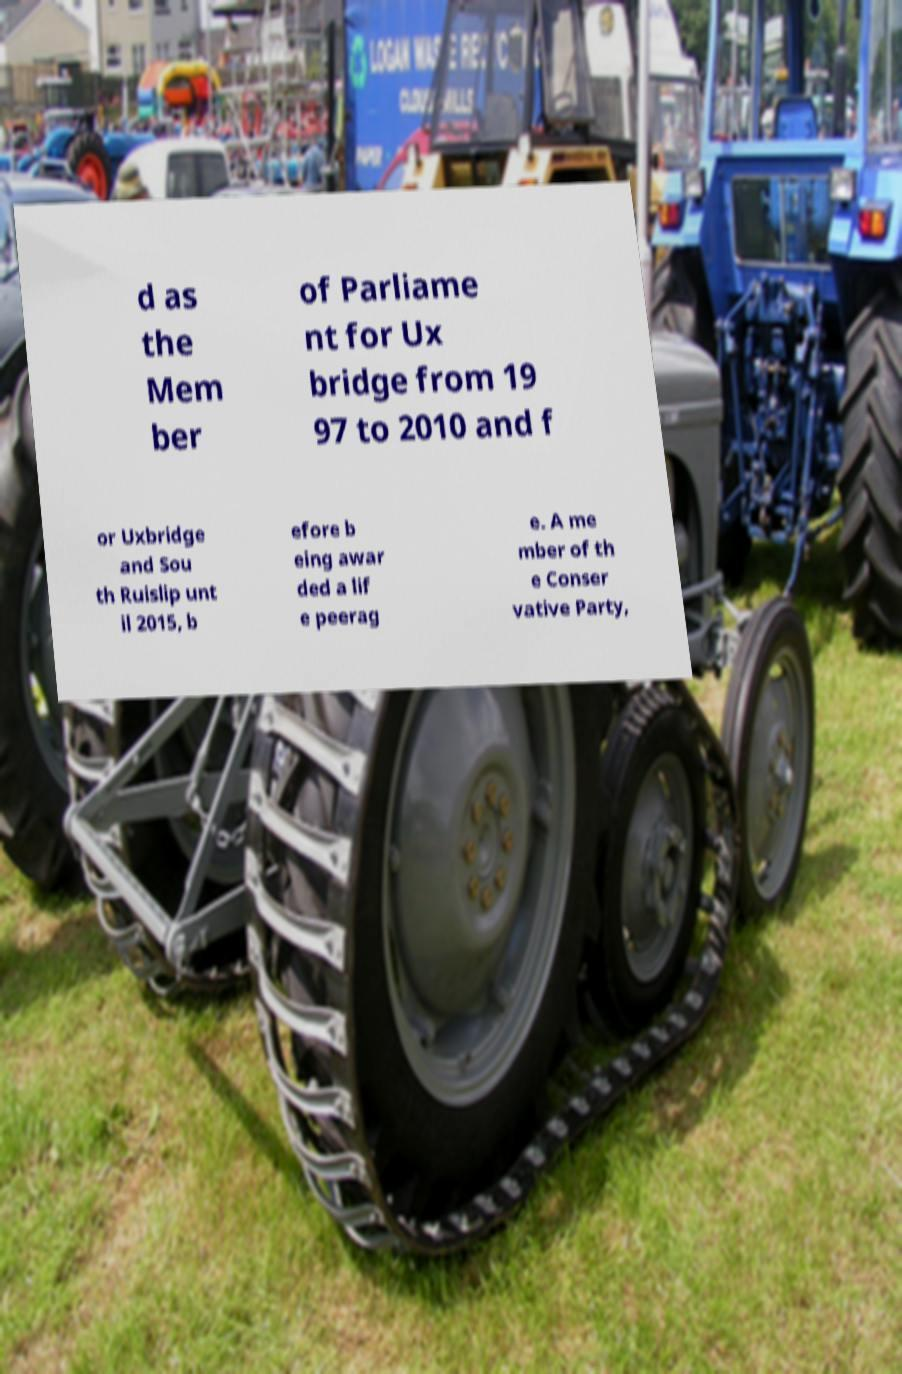Could you extract and type out the text from this image? d as the Mem ber of Parliame nt for Ux bridge from 19 97 to 2010 and f or Uxbridge and Sou th Ruislip unt il 2015, b efore b eing awar ded a lif e peerag e. A me mber of th e Conser vative Party, 